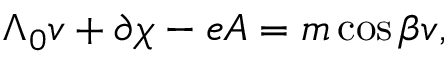Convert formula to latex. <formula><loc_0><loc_0><loc_500><loc_500>\Lambda _ { 0 } v + \partial \chi - e A = m \cos { \beta } v ,</formula> 